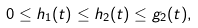Convert formula to latex. <formula><loc_0><loc_0><loc_500><loc_500>0 \leq h _ { 1 } ( t ) \leq h _ { 2 } ( t ) \leq g _ { 2 } ( t ) ,</formula> 